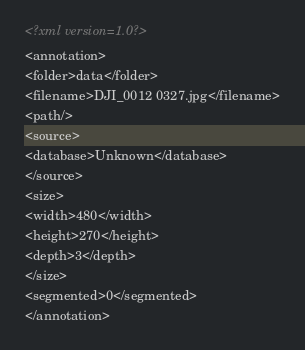Convert code to text. <code><loc_0><loc_0><loc_500><loc_500><_XML_><?xml version=1.0?>
<annotation>
<folder>data</folder>
<filename>DJI_0012 0327.jpg</filename>
<path/>
<source>
<database>Unknown</database>
</source>
<size>
<width>480</width>
<height>270</height>
<depth>3</depth>
</size>
<segmented>0</segmented>
</annotation></code> 